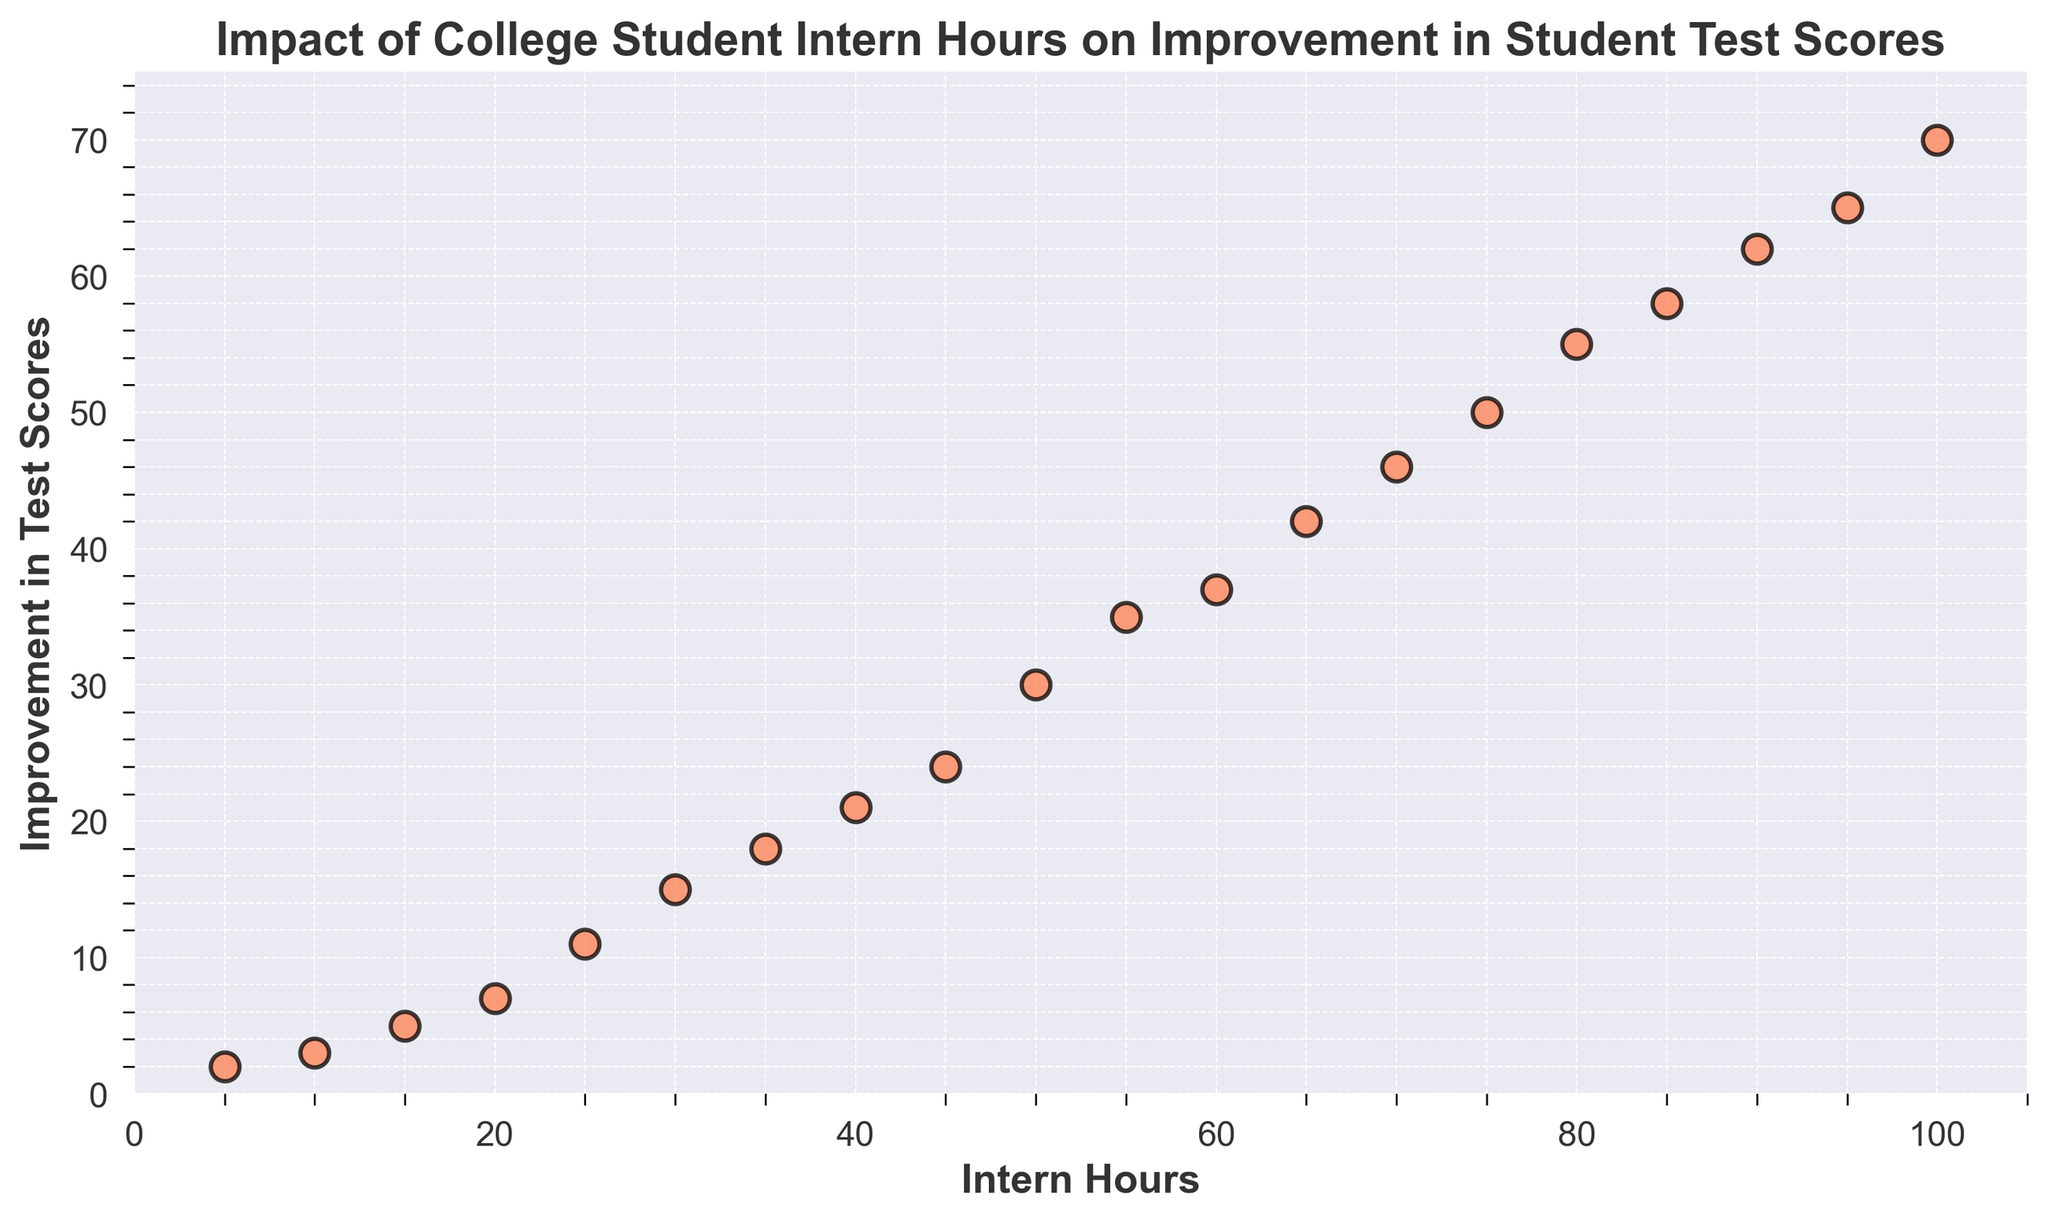What is the highest number of intern hours recorded in the figure? The scatter plot shows intern hours ranging from the lowest to the highest value. By looking at the far right of the x-axis, we can see the highest point, which corresponds to 100 intern hours.
Answer: 100 What improvement in student test scores is associated with 45 intern hours? Locate the data point along the x-axis at 45 intern hours, then follow it vertically to the y-axis to find the corresponding value in improvement in test scores.
Answer: 24 Are improvements in student test scores consistently increasing with more intern hours? By observing the scatter plot distribution, we can see that as intern hours increase from left to right, the corresponding improvement in student test scores also increases consistently, indicating a positive trend.
Answer: Yes What is the increase in test scores for each additional 10 intern hours on average? Calculate the average rate by comparing the increase between several intervals of 10 intern hours. Examples: (10 to 20 hours = +4), (20 to 30 hours = +8), (30 to 40 hours = +6). Averaging these values: (4+8+6)/3 = 6.
Answer: 6 Which data point has the largest difference between intern hours and improvement in student test scores? By examining all data points, the data point at 50 intern hours has a corresponding test score improvement of 30, while the data point at 55 intern hours has a difference of 20 (Intern hours 100 and improvement 70). The point with intern hours 55 and improvement 35 has the largest difference.
Answer: 55 intern hours and 35 improvement At what intern hour mark does the improvement in student test scores reach 50? Look for the data point where the y-axis value reaches 50. This corresponds to the x-axis value at 75 intern hours.
Answer: 75 Do any intern hours show no improvement in student test scores? By analyzing the scatter plot, we can see there is no intern hour value where the improvement in student test scores is zero. Even the smallest intern hour value of 5 shows some improvement.
Answer: No Compare the difference in improvement between 15 intern hours and 60 intern hours. Locate the points for 15 intern hours (5 improvement) and 60 intern hours (37 improvement). The difference is 37 - 5 = 32.
Answer: 32 What is the improvement in student test scores at 100 intern hours? By locating the data point at the maximum intern hour value of 100, we can look at the corresponding y-axis value, which is 70.
Answer: 70 